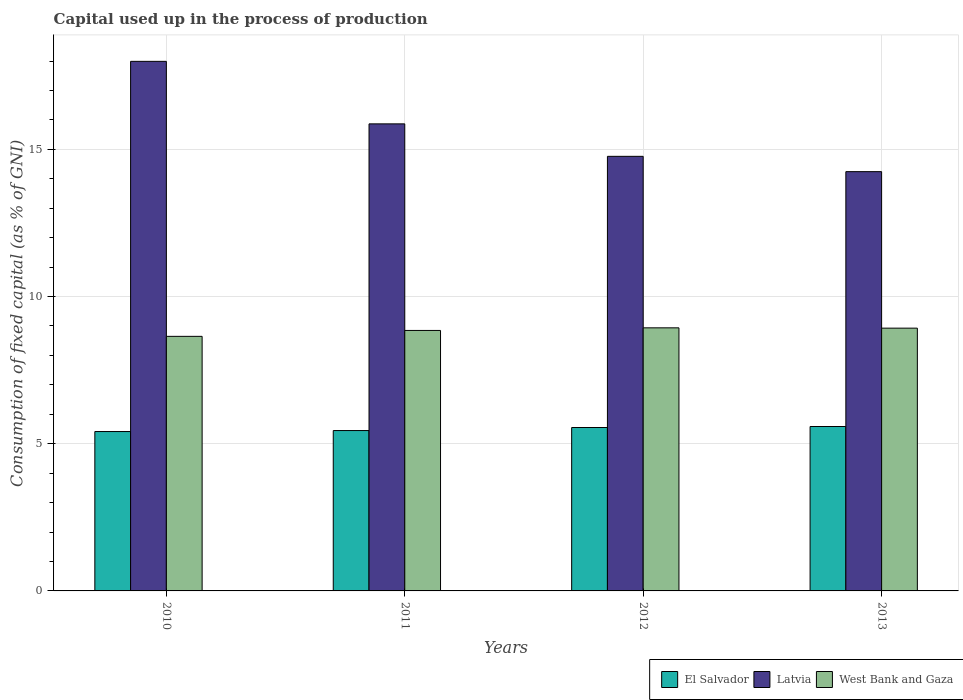How many groups of bars are there?
Your answer should be very brief. 4. Are the number of bars per tick equal to the number of legend labels?
Give a very brief answer. Yes. How many bars are there on the 4th tick from the left?
Offer a terse response. 3. How many bars are there on the 4th tick from the right?
Give a very brief answer. 3. What is the label of the 3rd group of bars from the left?
Ensure brevity in your answer.  2012. In how many cases, is the number of bars for a given year not equal to the number of legend labels?
Make the answer very short. 0. What is the capital used up in the process of production in El Salvador in 2011?
Provide a short and direct response. 5.45. Across all years, what is the maximum capital used up in the process of production in El Salvador?
Offer a very short reply. 5.59. Across all years, what is the minimum capital used up in the process of production in West Bank and Gaza?
Ensure brevity in your answer.  8.65. What is the total capital used up in the process of production in Latvia in the graph?
Provide a succinct answer. 62.86. What is the difference between the capital used up in the process of production in El Salvador in 2010 and that in 2013?
Your response must be concise. -0.17. What is the difference between the capital used up in the process of production in El Salvador in 2011 and the capital used up in the process of production in West Bank and Gaza in 2010?
Offer a terse response. -3.2. What is the average capital used up in the process of production in Latvia per year?
Your answer should be compact. 15.72. In the year 2010, what is the difference between the capital used up in the process of production in West Bank and Gaza and capital used up in the process of production in Latvia?
Give a very brief answer. -9.34. What is the ratio of the capital used up in the process of production in El Salvador in 2011 to that in 2012?
Give a very brief answer. 0.98. Is the capital used up in the process of production in West Bank and Gaza in 2011 less than that in 2013?
Provide a short and direct response. Yes. What is the difference between the highest and the second highest capital used up in the process of production in West Bank and Gaza?
Offer a very short reply. 0.01. What is the difference between the highest and the lowest capital used up in the process of production in El Salvador?
Offer a terse response. 0.17. What does the 3rd bar from the left in 2012 represents?
Your response must be concise. West Bank and Gaza. What does the 2nd bar from the right in 2011 represents?
Give a very brief answer. Latvia. How many bars are there?
Your answer should be compact. 12. Are all the bars in the graph horizontal?
Offer a very short reply. No. What is the difference between two consecutive major ticks on the Y-axis?
Your answer should be compact. 5. Are the values on the major ticks of Y-axis written in scientific E-notation?
Your response must be concise. No. Where does the legend appear in the graph?
Provide a succinct answer. Bottom right. How are the legend labels stacked?
Make the answer very short. Horizontal. What is the title of the graph?
Give a very brief answer. Capital used up in the process of production. What is the label or title of the Y-axis?
Give a very brief answer. Consumption of fixed capital (as % of GNI). What is the Consumption of fixed capital (as % of GNI) in El Salvador in 2010?
Keep it short and to the point. 5.41. What is the Consumption of fixed capital (as % of GNI) in Latvia in 2010?
Your answer should be very brief. 17.99. What is the Consumption of fixed capital (as % of GNI) in West Bank and Gaza in 2010?
Your response must be concise. 8.65. What is the Consumption of fixed capital (as % of GNI) in El Salvador in 2011?
Give a very brief answer. 5.45. What is the Consumption of fixed capital (as % of GNI) in Latvia in 2011?
Make the answer very short. 15.87. What is the Consumption of fixed capital (as % of GNI) of West Bank and Gaza in 2011?
Keep it short and to the point. 8.85. What is the Consumption of fixed capital (as % of GNI) in El Salvador in 2012?
Offer a very short reply. 5.55. What is the Consumption of fixed capital (as % of GNI) of Latvia in 2012?
Your answer should be very brief. 14.76. What is the Consumption of fixed capital (as % of GNI) of West Bank and Gaza in 2012?
Your answer should be compact. 8.94. What is the Consumption of fixed capital (as % of GNI) in El Salvador in 2013?
Offer a terse response. 5.59. What is the Consumption of fixed capital (as % of GNI) of Latvia in 2013?
Ensure brevity in your answer.  14.24. What is the Consumption of fixed capital (as % of GNI) in West Bank and Gaza in 2013?
Keep it short and to the point. 8.93. Across all years, what is the maximum Consumption of fixed capital (as % of GNI) of El Salvador?
Provide a short and direct response. 5.59. Across all years, what is the maximum Consumption of fixed capital (as % of GNI) of Latvia?
Offer a terse response. 17.99. Across all years, what is the maximum Consumption of fixed capital (as % of GNI) in West Bank and Gaza?
Offer a terse response. 8.94. Across all years, what is the minimum Consumption of fixed capital (as % of GNI) in El Salvador?
Your answer should be very brief. 5.41. Across all years, what is the minimum Consumption of fixed capital (as % of GNI) of Latvia?
Provide a succinct answer. 14.24. Across all years, what is the minimum Consumption of fixed capital (as % of GNI) in West Bank and Gaza?
Make the answer very short. 8.65. What is the total Consumption of fixed capital (as % of GNI) of El Salvador in the graph?
Keep it short and to the point. 22. What is the total Consumption of fixed capital (as % of GNI) in Latvia in the graph?
Offer a very short reply. 62.86. What is the total Consumption of fixed capital (as % of GNI) in West Bank and Gaza in the graph?
Provide a succinct answer. 35.36. What is the difference between the Consumption of fixed capital (as % of GNI) in El Salvador in 2010 and that in 2011?
Offer a very short reply. -0.03. What is the difference between the Consumption of fixed capital (as % of GNI) of Latvia in 2010 and that in 2011?
Provide a short and direct response. 2.12. What is the difference between the Consumption of fixed capital (as % of GNI) of West Bank and Gaza in 2010 and that in 2011?
Offer a terse response. -0.2. What is the difference between the Consumption of fixed capital (as % of GNI) of El Salvador in 2010 and that in 2012?
Offer a terse response. -0.14. What is the difference between the Consumption of fixed capital (as % of GNI) of Latvia in 2010 and that in 2012?
Provide a short and direct response. 3.23. What is the difference between the Consumption of fixed capital (as % of GNI) in West Bank and Gaza in 2010 and that in 2012?
Your answer should be compact. -0.29. What is the difference between the Consumption of fixed capital (as % of GNI) of El Salvador in 2010 and that in 2013?
Provide a short and direct response. -0.17. What is the difference between the Consumption of fixed capital (as % of GNI) of Latvia in 2010 and that in 2013?
Your answer should be compact. 3.75. What is the difference between the Consumption of fixed capital (as % of GNI) in West Bank and Gaza in 2010 and that in 2013?
Offer a very short reply. -0.28. What is the difference between the Consumption of fixed capital (as % of GNI) in El Salvador in 2011 and that in 2012?
Your answer should be compact. -0.1. What is the difference between the Consumption of fixed capital (as % of GNI) of Latvia in 2011 and that in 2012?
Provide a short and direct response. 1.1. What is the difference between the Consumption of fixed capital (as % of GNI) in West Bank and Gaza in 2011 and that in 2012?
Make the answer very short. -0.09. What is the difference between the Consumption of fixed capital (as % of GNI) of El Salvador in 2011 and that in 2013?
Give a very brief answer. -0.14. What is the difference between the Consumption of fixed capital (as % of GNI) of Latvia in 2011 and that in 2013?
Make the answer very short. 1.62. What is the difference between the Consumption of fixed capital (as % of GNI) in West Bank and Gaza in 2011 and that in 2013?
Give a very brief answer. -0.08. What is the difference between the Consumption of fixed capital (as % of GNI) of El Salvador in 2012 and that in 2013?
Provide a short and direct response. -0.03. What is the difference between the Consumption of fixed capital (as % of GNI) in Latvia in 2012 and that in 2013?
Provide a succinct answer. 0.52. What is the difference between the Consumption of fixed capital (as % of GNI) in West Bank and Gaza in 2012 and that in 2013?
Make the answer very short. 0.01. What is the difference between the Consumption of fixed capital (as % of GNI) of El Salvador in 2010 and the Consumption of fixed capital (as % of GNI) of Latvia in 2011?
Provide a succinct answer. -10.45. What is the difference between the Consumption of fixed capital (as % of GNI) in El Salvador in 2010 and the Consumption of fixed capital (as % of GNI) in West Bank and Gaza in 2011?
Offer a very short reply. -3.43. What is the difference between the Consumption of fixed capital (as % of GNI) in Latvia in 2010 and the Consumption of fixed capital (as % of GNI) in West Bank and Gaza in 2011?
Your response must be concise. 9.14. What is the difference between the Consumption of fixed capital (as % of GNI) of El Salvador in 2010 and the Consumption of fixed capital (as % of GNI) of Latvia in 2012?
Give a very brief answer. -9.35. What is the difference between the Consumption of fixed capital (as % of GNI) in El Salvador in 2010 and the Consumption of fixed capital (as % of GNI) in West Bank and Gaza in 2012?
Provide a short and direct response. -3.52. What is the difference between the Consumption of fixed capital (as % of GNI) in Latvia in 2010 and the Consumption of fixed capital (as % of GNI) in West Bank and Gaza in 2012?
Offer a very short reply. 9.05. What is the difference between the Consumption of fixed capital (as % of GNI) of El Salvador in 2010 and the Consumption of fixed capital (as % of GNI) of Latvia in 2013?
Offer a terse response. -8.83. What is the difference between the Consumption of fixed capital (as % of GNI) in El Salvador in 2010 and the Consumption of fixed capital (as % of GNI) in West Bank and Gaza in 2013?
Offer a terse response. -3.51. What is the difference between the Consumption of fixed capital (as % of GNI) in Latvia in 2010 and the Consumption of fixed capital (as % of GNI) in West Bank and Gaza in 2013?
Your response must be concise. 9.06. What is the difference between the Consumption of fixed capital (as % of GNI) of El Salvador in 2011 and the Consumption of fixed capital (as % of GNI) of Latvia in 2012?
Ensure brevity in your answer.  -9.32. What is the difference between the Consumption of fixed capital (as % of GNI) of El Salvador in 2011 and the Consumption of fixed capital (as % of GNI) of West Bank and Gaza in 2012?
Provide a succinct answer. -3.49. What is the difference between the Consumption of fixed capital (as % of GNI) of Latvia in 2011 and the Consumption of fixed capital (as % of GNI) of West Bank and Gaza in 2012?
Your response must be concise. 6.93. What is the difference between the Consumption of fixed capital (as % of GNI) of El Salvador in 2011 and the Consumption of fixed capital (as % of GNI) of Latvia in 2013?
Your answer should be very brief. -8.8. What is the difference between the Consumption of fixed capital (as % of GNI) of El Salvador in 2011 and the Consumption of fixed capital (as % of GNI) of West Bank and Gaza in 2013?
Ensure brevity in your answer.  -3.48. What is the difference between the Consumption of fixed capital (as % of GNI) of Latvia in 2011 and the Consumption of fixed capital (as % of GNI) of West Bank and Gaza in 2013?
Provide a succinct answer. 6.94. What is the difference between the Consumption of fixed capital (as % of GNI) of El Salvador in 2012 and the Consumption of fixed capital (as % of GNI) of Latvia in 2013?
Make the answer very short. -8.69. What is the difference between the Consumption of fixed capital (as % of GNI) in El Salvador in 2012 and the Consumption of fixed capital (as % of GNI) in West Bank and Gaza in 2013?
Offer a very short reply. -3.38. What is the difference between the Consumption of fixed capital (as % of GNI) of Latvia in 2012 and the Consumption of fixed capital (as % of GNI) of West Bank and Gaza in 2013?
Ensure brevity in your answer.  5.84. What is the average Consumption of fixed capital (as % of GNI) of El Salvador per year?
Offer a very short reply. 5.5. What is the average Consumption of fixed capital (as % of GNI) of Latvia per year?
Ensure brevity in your answer.  15.72. What is the average Consumption of fixed capital (as % of GNI) of West Bank and Gaza per year?
Offer a very short reply. 8.84. In the year 2010, what is the difference between the Consumption of fixed capital (as % of GNI) in El Salvador and Consumption of fixed capital (as % of GNI) in Latvia?
Your response must be concise. -12.58. In the year 2010, what is the difference between the Consumption of fixed capital (as % of GNI) in El Salvador and Consumption of fixed capital (as % of GNI) in West Bank and Gaza?
Your answer should be very brief. -3.23. In the year 2010, what is the difference between the Consumption of fixed capital (as % of GNI) of Latvia and Consumption of fixed capital (as % of GNI) of West Bank and Gaza?
Keep it short and to the point. 9.34. In the year 2011, what is the difference between the Consumption of fixed capital (as % of GNI) in El Salvador and Consumption of fixed capital (as % of GNI) in Latvia?
Keep it short and to the point. -10.42. In the year 2011, what is the difference between the Consumption of fixed capital (as % of GNI) of El Salvador and Consumption of fixed capital (as % of GNI) of West Bank and Gaza?
Provide a short and direct response. -3.4. In the year 2011, what is the difference between the Consumption of fixed capital (as % of GNI) in Latvia and Consumption of fixed capital (as % of GNI) in West Bank and Gaza?
Offer a terse response. 7.02. In the year 2012, what is the difference between the Consumption of fixed capital (as % of GNI) in El Salvador and Consumption of fixed capital (as % of GNI) in Latvia?
Your answer should be very brief. -9.21. In the year 2012, what is the difference between the Consumption of fixed capital (as % of GNI) in El Salvador and Consumption of fixed capital (as % of GNI) in West Bank and Gaza?
Provide a succinct answer. -3.39. In the year 2012, what is the difference between the Consumption of fixed capital (as % of GNI) in Latvia and Consumption of fixed capital (as % of GNI) in West Bank and Gaza?
Offer a very short reply. 5.83. In the year 2013, what is the difference between the Consumption of fixed capital (as % of GNI) in El Salvador and Consumption of fixed capital (as % of GNI) in Latvia?
Keep it short and to the point. -8.66. In the year 2013, what is the difference between the Consumption of fixed capital (as % of GNI) of El Salvador and Consumption of fixed capital (as % of GNI) of West Bank and Gaza?
Provide a succinct answer. -3.34. In the year 2013, what is the difference between the Consumption of fixed capital (as % of GNI) in Latvia and Consumption of fixed capital (as % of GNI) in West Bank and Gaza?
Ensure brevity in your answer.  5.32. What is the ratio of the Consumption of fixed capital (as % of GNI) of Latvia in 2010 to that in 2011?
Keep it short and to the point. 1.13. What is the ratio of the Consumption of fixed capital (as % of GNI) of West Bank and Gaza in 2010 to that in 2011?
Offer a terse response. 0.98. What is the ratio of the Consumption of fixed capital (as % of GNI) of El Salvador in 2010 to that in 2012?
Provide a short and direct response. 0.98. What is the ratio of the Consumption of fixed capital (as % of GNI) of Latvia in 2010 to that in 2012?
Provide a short and direct response. 1.22. What is the ratio of the Consumption of fixed capital (as % of GNI) in West Bank and Gaza in 2010 to that in 2012?
Your answer should be compact. 0.97. What is the ratio of the Consumption of fixed capital (as % of GNI) in El Salvador in 2010 to that in 2013?
Provide a succinct answer. 0.97. What is the ratio of the Consumption of fixed capital (as % of GNI) in Latvia in 2010 to that in 2013?
Your answer should be very brief. 1.26. What is the ratio of the Consumption of fixed capital (as % of GNI) in West Bank and Gaza in 2010 to that in 2013?
Ensure brevity in your answer.  0.97. What is the ratio of the Consumption of fixed capital (as % of GNI) in El Salvador in 2011 to that in 2012?
Offer a terse response. 0.98. What is the ratio of the Consumption of fixed capital (as % of GNI) in Latvia in 2011 to that in 2012?
Keep it short and to the point. 1.07. What is the ratio of the Consumption of fixed capital (as % of GNI) of West Bank and Gaza in 2011 to that in 2012?
Your answer should be compact. 0.99. What is the ratio of the Consumption of fixed capital (as % of GNI) in El Salvador in 2011 to that in 2013?
Offer a very short reply. 0.98. What is the ratio of the Consumption of fixed capital (as % of GNI) in Latvia in 2011 to that in 2013?
Offer a terse response. 1.11. What is the ratio of the Consumption of fixed capital (as % of GNI) of Latvia in 2012 to that in 2013?
Make the answer very short. 1.04. What is the ratio of the Consumption of fixed capital (as % of GNI) in West Bank and Gaza in 2012 to that in 2013?
Your answer should be very brief. 1. What is the difference between the highest and the second highest Consumption of fixed capital (as % of GNI) of El Salvador?
Your answer should be very brief. 0.03. What is the difference between the highest and the second highest Consumption of fixed capital (as % of GNI) of Latvia?
Keep it short and to the point. 2.12. What is the difference between the highest and the second highest Consumption of fixed capital (as % of GNI) in West Bank and Gaza?
Keep it short and to the point. 0.01. What is the difference between the highest and the lowest Consumption of fixed capital (as % of GNI) in El Salvador?
Ensure brevity in your answer.  0.17. What is the difference between the highest and the lowest Consumption of fixed capital (as % of GNI) in Latvia?
Ensure brevity in your answer.  3.75. What is the difference between the highest and the lowest Consumption of fixed capital (as % of GNI) of West Bank and Gaza?
Your answer should be compact. 0.29. 